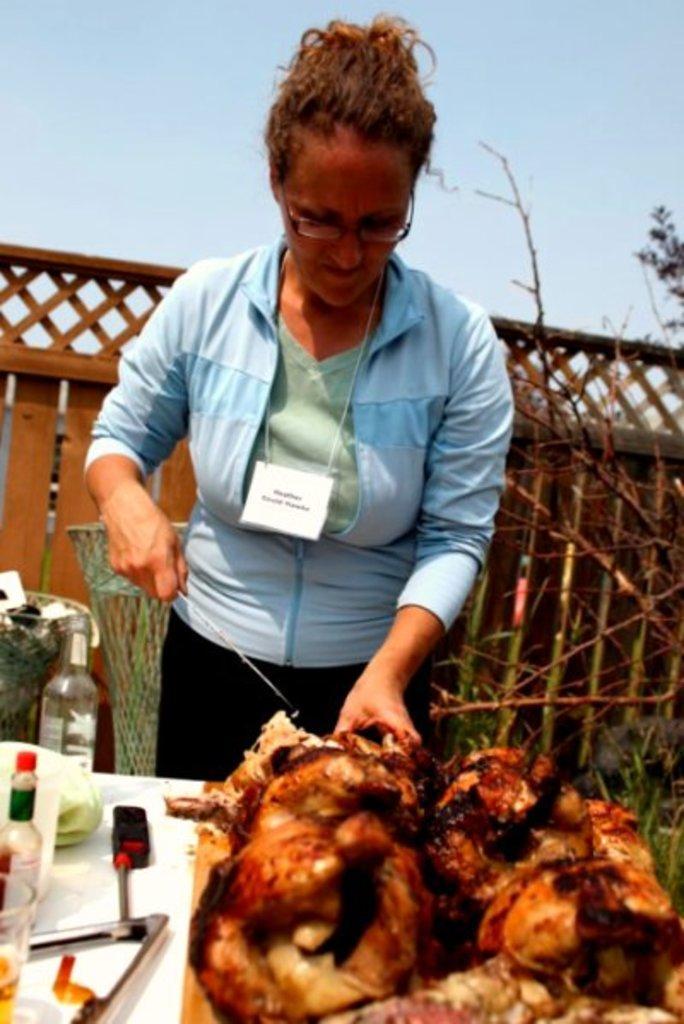Describe this image in one or two sentences. Here we can see a woman is standing, and holding something in the hand, and in front here is the table and some objects on it, and here is the sky. 